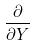<formula> <loc_0><loc_0><loc_500><loc_500>\frac { \partial } { \partial Y }</formula> 